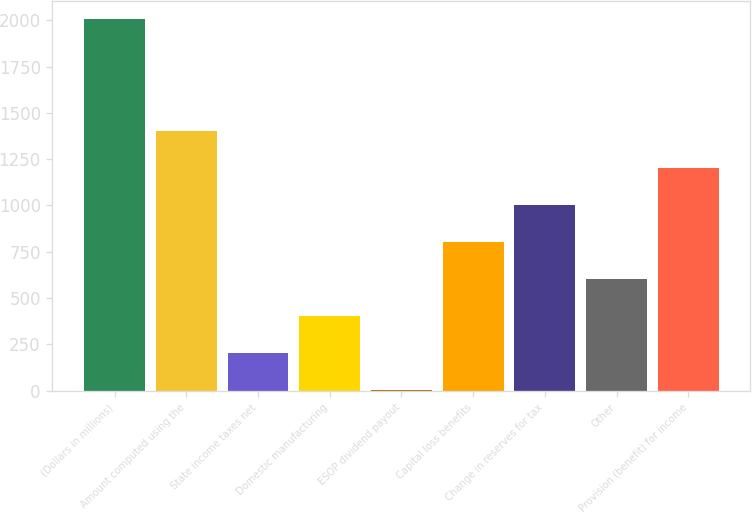Convert chart to OTSL. <chart><loc_0><loc_0><loc_500><loc_500><bar_chart><fcel>(Dollars in millions)<fcel>Amount computed using the<fcel>State income taxes net<fcel>Domestic manufacturing<fcel>ESOP dividend payout<fcel>Capital loss benefits<fcel>Change in reserves for tax<fcel>Other<fcel>Provision (benefit) for income<nl><fcel>2005<fcel>1404.1<fcel>202.3<fcel>402.6<fcel>2<fcel>803.2<fcel>1003.5<fcel>602.9<fcel>1203.8<nl></chart> 